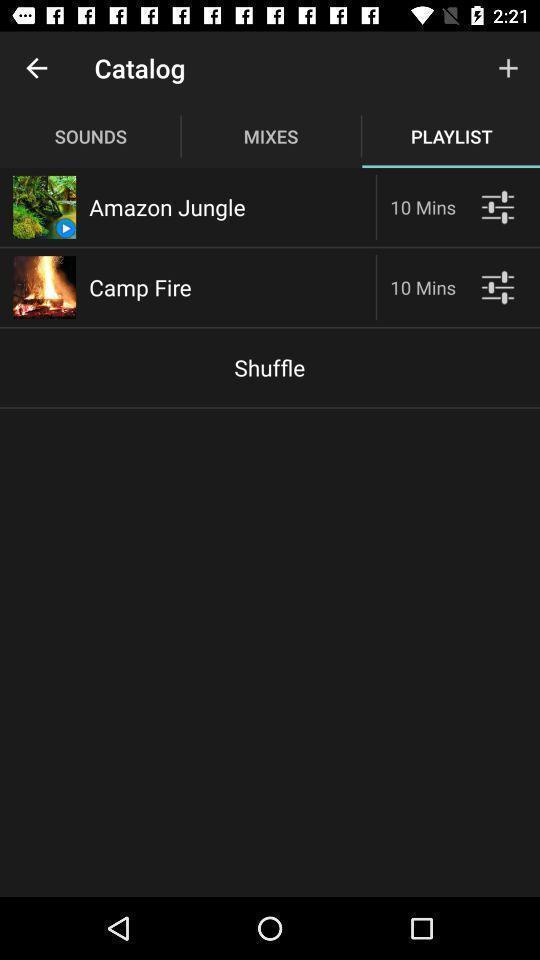Explain what's happening in this screen capture. Page displaying the playlist. 